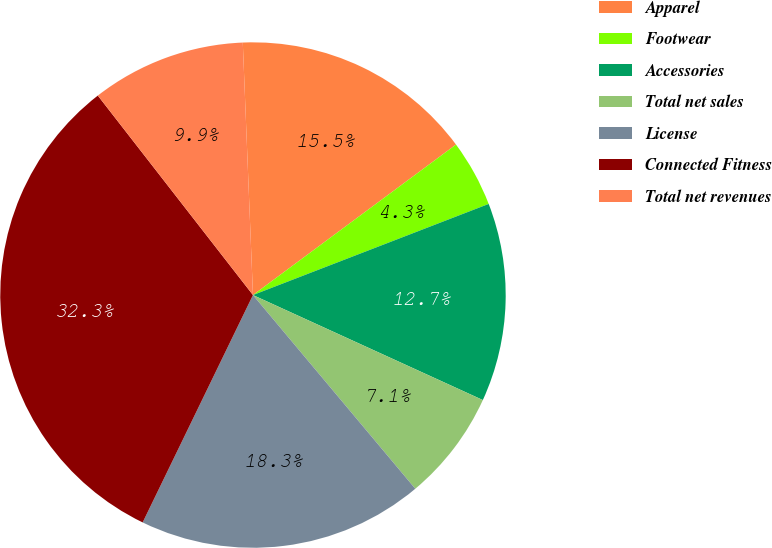<chart> <loc_0><loc_0><loc_500><loc_500><pie_chart><fcel>Apparel<fcel>Footwear<fcel>Accessories<fcel>Total net sales<fcel>License<fcel>Connected Fitness<fcel>Total net revenues<nl><fcel>15.49%<fcel>4.28%<fcel>12.69%<fcel>7.08%<fcel>18.29%<fcel>32.29%<fcel>9.88%<nl></chart> 